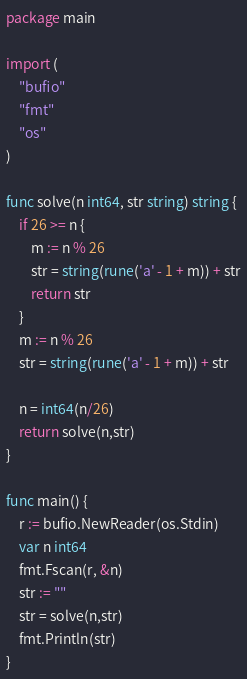Convert code to text. <code><loc_0><loc_0><loc_500><loc_500><_Go_>package main

import (
	"bufio"
	"fmt"
	"os"
)

func solve(n int64, str string) string {
	if 26 >= n {
		m := n % 26
		str = string(rune('a' - 1 + m)) + str
		return str
	}
	m := n % 26
	str = string(rune('a' - 1 + m)) + str 

	n = int64(n/26)
    return solve(n,str)
}

func main() {
	r := bufio.NewReader(os.Stdin)
	var n int64
	fmt.Fscan(r, &n)
	str := ""
	str = solve(n,str)
	fmt.Println(str)
}
</code> 